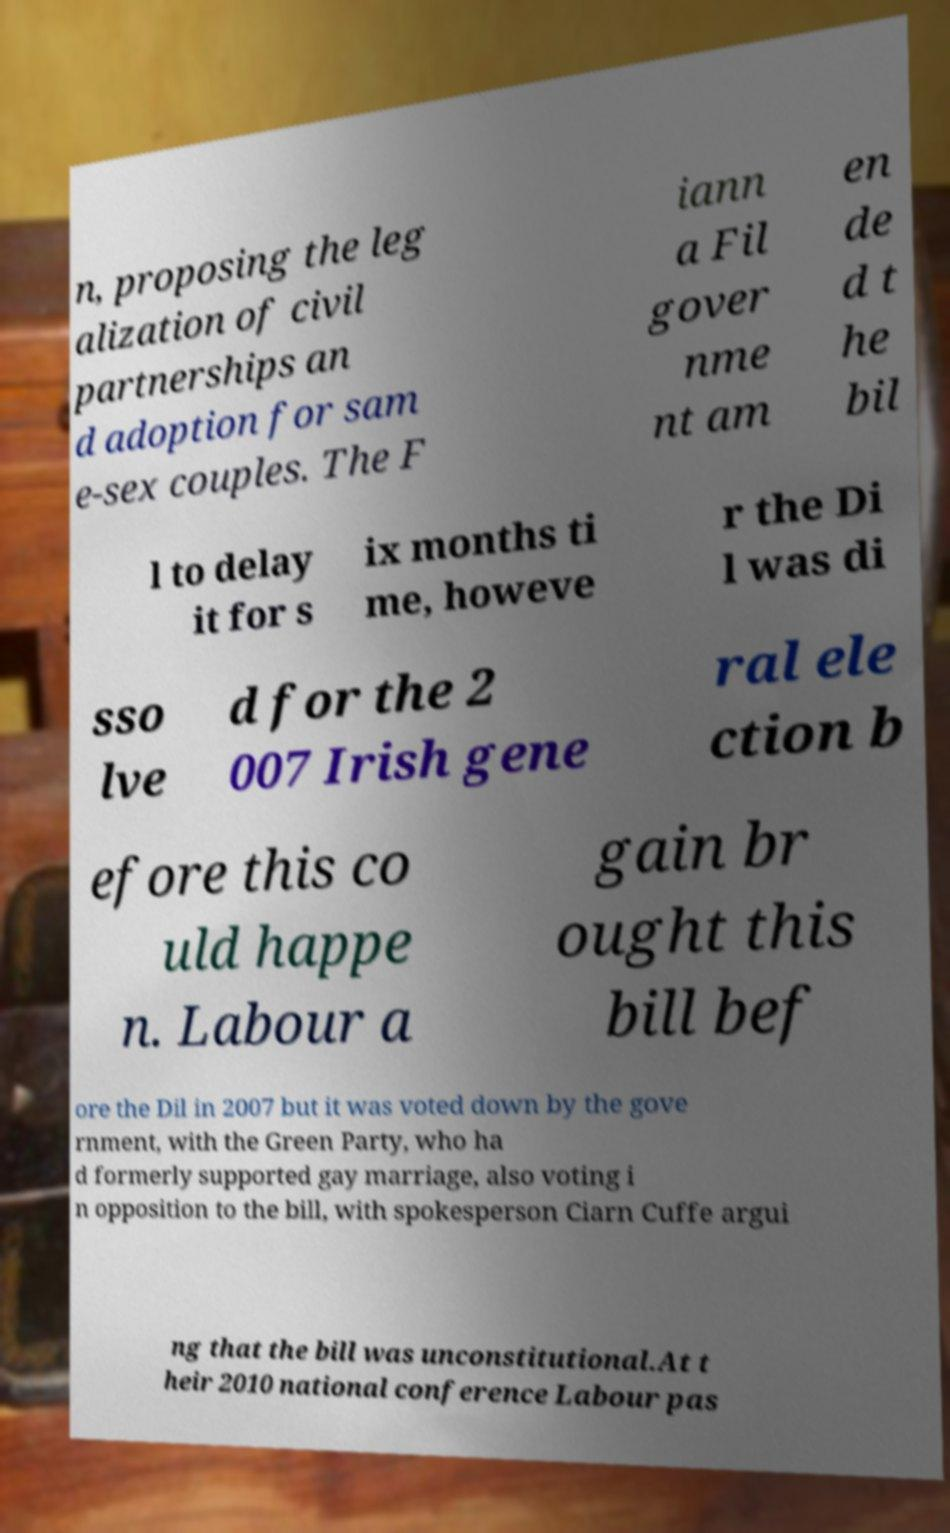For documentation purposes, I need the text within this image transcribed. Could you provide that? n, proposing the leg alization of civil partnerships an d adoption for sam e-sex couples. The F iann a Fil gover nme nt am en de d t he bil l to delay it for s ix months ti me, howeve r the Di l was di sso lve d for the 2 007 Irish gene ral ele ction b efore this co uld happe n. Labour a gain br ought this bill bef ore the Dil in 2007 but it was voted down by the gove rnment, with the Green Party, who ha d formerly supported gay marriage, also voting i n opposition to the bill, with spokesperson Ciarn Cuffe argui ng that the bill was unconstitutional.At t heir 2010 national conference Labour pas 